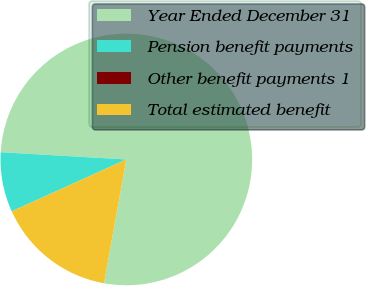Convert chart. <chart><loc_0><loc_0><loc_500><loc_500><pie_chart><fcel>Year Ended December 31<fcel>Pension benefit payments<fcel>Other benefit payments 1<fcel>Total estimated benefit<nl><fcel>76.92%<fcel>7.69%<fcel>0.0%<fcel>15.39%<nl></chart> 